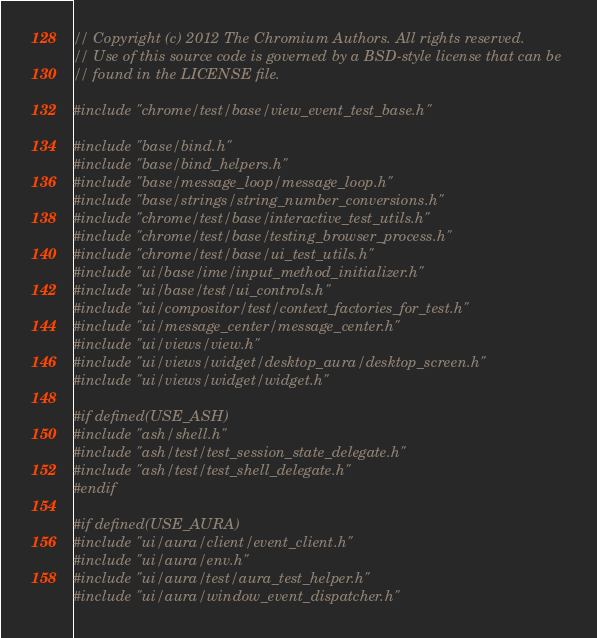Convert code to text. <code><loc_0><loc_0><loc_500><loc_500><_C++_>// Copyright (c) 2012 The Chromium Authors. All rights reserved.
// Use of this source code is governed by a BSD-style license that can be
// found in the LICENSE file.

#include "chrome/test/base/view_event_test_base.h"

#include "base/bind.h"
#include "base/bind_helpers.h"
#include "base/message_loop/message_loop.h"
#include "base/strings/string_number_conversions.h"
#include "chrome/test/base/interactive_test_utils.h"
#include "chrome/test/base/testing_browser_process.h"
#include "chrome/test/base/ui_test_utils.h"
#include "ui/base/ime/input_method_initializer.h"
#include "ui/base/test/ui_controls.h"
#include "ui/compositor/test/context_factories_for_test.h"
#include "ui/message_center/message_center.h"
#include "ui/views/view.h"
#include "ui/views/widget/desktop_aura/desktop_screen.h"
#include "ui/views/widget/widget.h"

#if defined(USE_ASH)
#include "ash/shell.h"
#include "ash/test/test_session_state_delegate.h"
#include "ash/test/test_shell_delegate.h"
#endif

#if defined(USE_AURA)
#include "ui/aura/client/event_client.h"
#include "ui/aura/env.h"
#include "ui/aura/test/aura_test_helper.h"
#include "ui/aura/window_event_dispatcher.h"</code> 